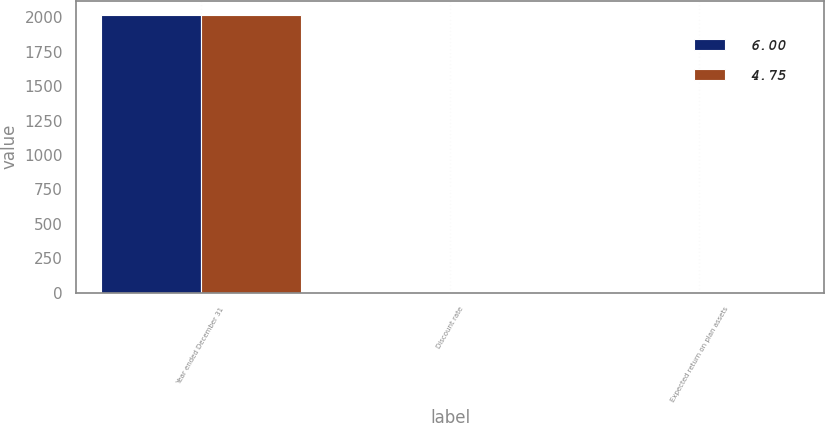Convert chart to OTSL. <chart><loc_0><loc_0><loc_500><loc_500><stacked_bar_chart><ecel><fcel>Year ended December 31<fcel>Discount rate<fcel>Expected return on plan assets<nl><fcel>6<fcel>2018<fcel>3.25<fcel>4.75<nl><fcel>4.75<fcel>2017<fcel>3.75<fcel>6<nl></chart> 